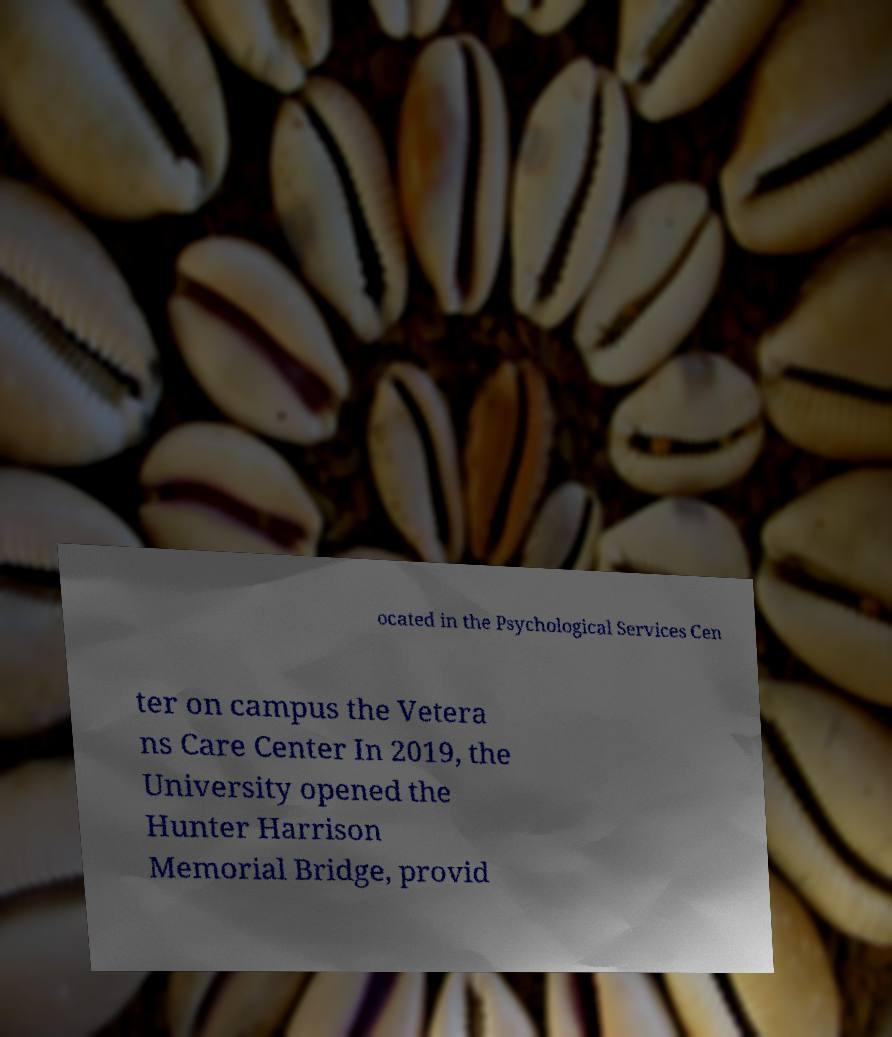I need the written content from this picture converted into text. Can you do that? ocated in the Psychological Services Cen ter on campus the Vetera ns Care Center In 2019, the University opened the Hunter Harrison Memorial Bridge, provid 